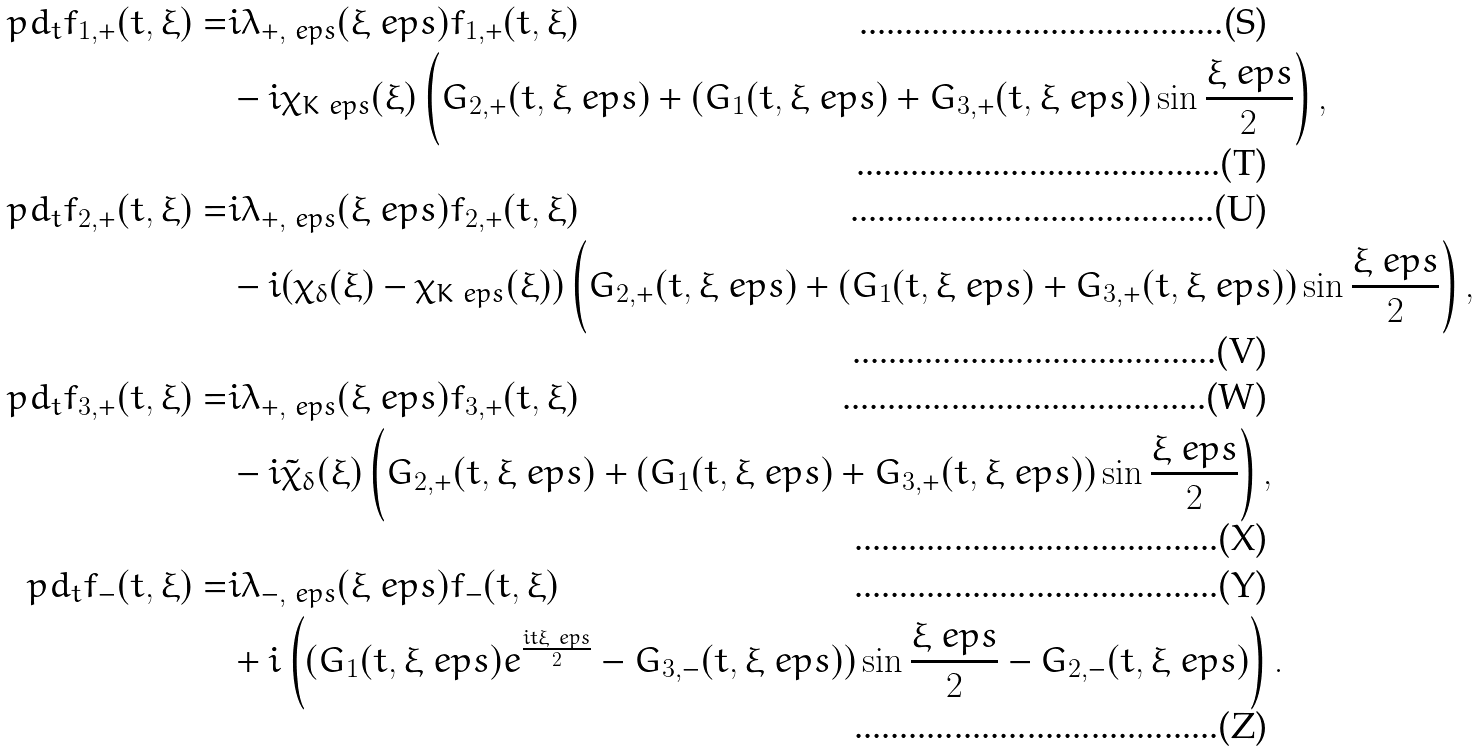Convert formula to latex. <formula><loc_0><loc_0><loc_500><loc_500>\ p d _ { t } f _ { 1 , + } ( t , \xi ) = & i \lambda _ { + , \ e p s } ( \xi _ { \ } e p s ) f _ { 1 , + } ( t , \xi ) \\ & - i \chi _ { K \ e p s } ( \xi ) \left ( G _ { 2 , + } ( t , \xi _ { \ } e p s ) + ( G _ { 1 } ( t , \xi _ { \ } e p s ) + G _ { 3 , + } ( t , \xi _ { \ } e p s ) ) \sin \frac { \xi _ { \ } e p s } 2 \right ) , \\ \ p d _ { t } f _ { 2 , + } ( t , \xi ) = & i \lambda _ { + , \ e p s } ( \xi _ { \ } e p s ) f _ { 2 , + } ( t , \xi ) \\ & - i ( \chi _ { \delta } ( \xi ) - \chi _ { K \ e p s } ( \xi ) ) \left ( G _ { 2 , + } ( t , \xi _ { \ } e p s ) + ( G _ { 1 } ( t , \xi _ { \ } e p s ) + G _ { 3 , + } ( t , \xi _ { \ } e p s ) ) \sin \frac { \xi _ { \ } e p s } 2 \right ) , \\ \ p d _ { t } f _ { 3 , + } ( t , \xi ) = & i \lambda _ { + , \ e p s } ( \xi _ { \ } e p s ) f _ { 3 , + } ( t , \xi ) \\ & - i \tilde { \chi } _ { \delta } ( \xi ) \left ( G _ { 2 , + } ( t , \xi _ { \ } e p s ) + ( G _ { 1 } ( t , \xi _ { \ } e p s ) + G _ { 3 , + } ( t , \xi _ { \ } e p s ) ) \sin \frac { \xi _ { \ } e p s } 2 \right ) , \\ \ p d _ { t } f _ { - } ( t , \xi ) = & i \lambda _ { - , \ e p s } ( \xi _ { \ } e p s ) f _ { - } ( t , \xi ) \\ & + i \left ( ( G _ { 1 } ( t , \xi _ { \ } e p s ) e ^ { \frac { i t \xi _ { \ } e p s } 2 } - G _ { 3 , - } ( t , \xi _ { \ } e p s ) ) \sin \frac { \xi _ { \ } e p s } { 2 } - G _ { 2 , - } ( t , \xi _ { \ } e p s ) \right ) .</formula> 